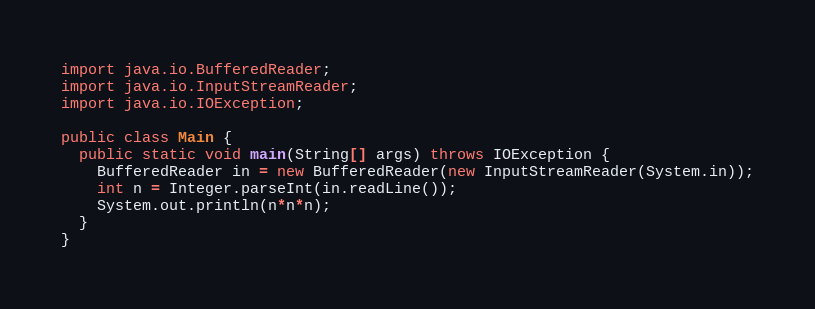<code> <loc_0><loc_0><loc_500><loc_500><_Java_>import java.io.BufferedReader;
import java.io.InputStreamReader;
import java.io.IOException;

public class Main {
  public static void main(String[] args) throws IOException {
    BufferedReader in = new BufferedReader(new InputStreamReader(System.in));
    int n = Integer.parseInt(in.readLine());
    System.out.println(n*n*n);
  }
}</code> 